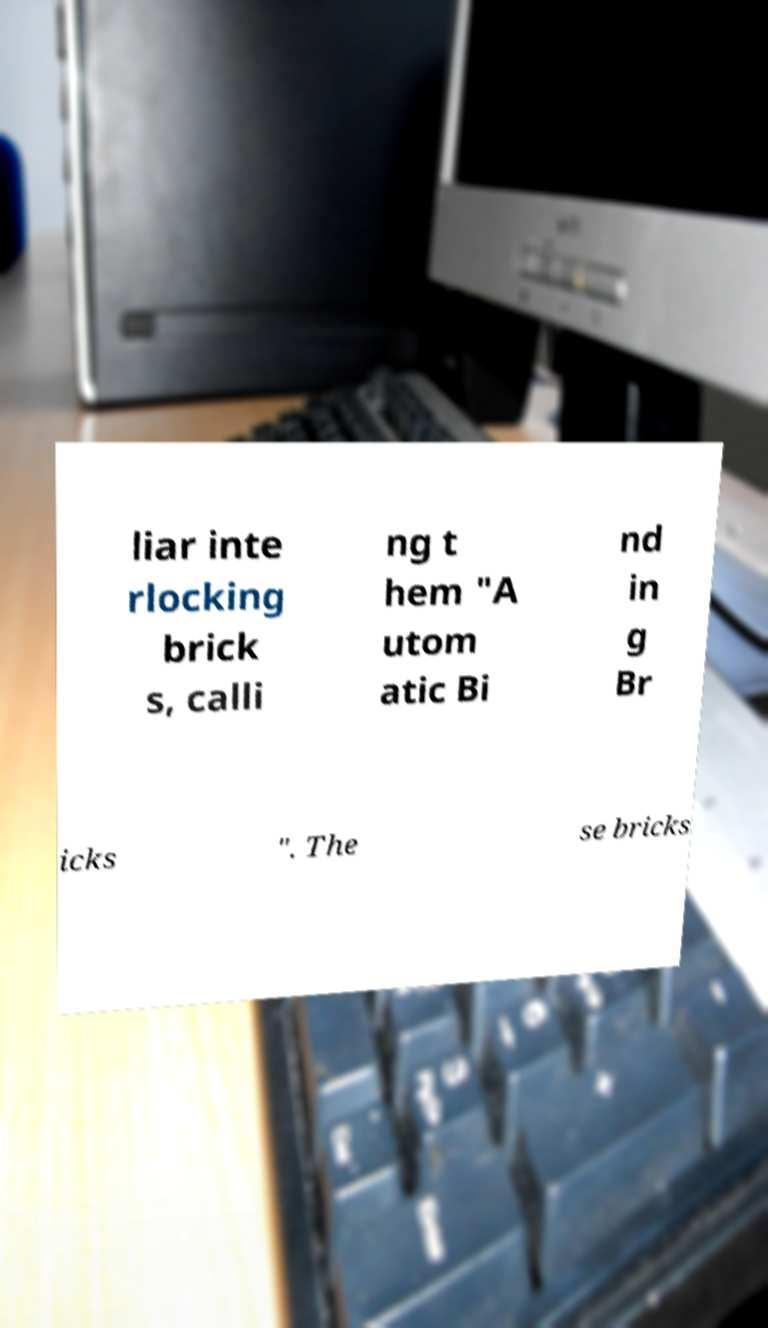What messages or text are displayed in this image? I need them in a readable, typed format. liar inte rlocking brick s, calli ng t hem "A utom atic Bi nd in g Br icks ". The se bricks 